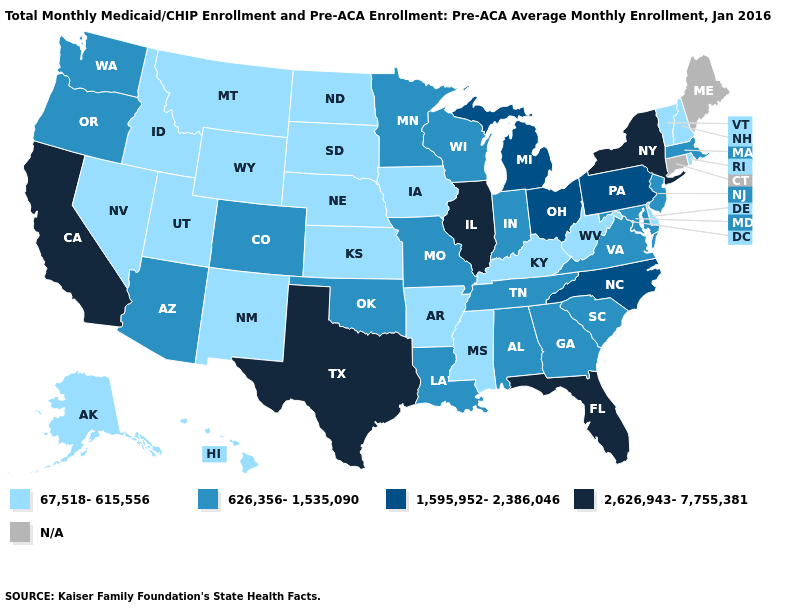Name the states that have a value in the range 1,595,952-2,386,046?
Short answer required. Michigan, North Carolina, Ohio, Pennsylvania. Does Washington have the highest value in the West?
Answer briefly. No. Name the states that have a value in the range 2,626,943-7,755,381?
Short answer required. California, Florida, Illinois, New York, Texas. What is the value of Arizona?
Short answer required. 626,356-1,535,090. Is the legend a continuous bar?
Be succinct. No. What is the value of Colorado?
Give a very brief answer. 626,356-1,535,090. Name the states that have a value in the range N/A?
Write a very short answer. Connecticut, Maine. What is the lowest value in the West?
Keep it brief. 67,518-615,556. Name the states that have a value in the range 626,356-1,535,090?
Keep it brief. Alabama, Arizona, Colorado, Georgia, Indiana, Louisiana, Maryland, Massachusetts, Minnesota, Missouri, New Jersey, Oklahoma, Oregon, South Carolina, Tennessee, Virginia, Washington, Wisconsin. What is the highest value in the USA?
Write a very short answer. 2,626,943-7,755,381. Which states have the highest value in the USA?
Keep it brief. California, Florida, Illinois, New York, Texas. What is the value of Connecticut?
Give a very brief answer. N/A. What is the value of Massachusetts?
Keep it brief. 626,356-1,535,090. Name the states that have a value in the range N/A?
Short answer required. Connecticut, Maine. 